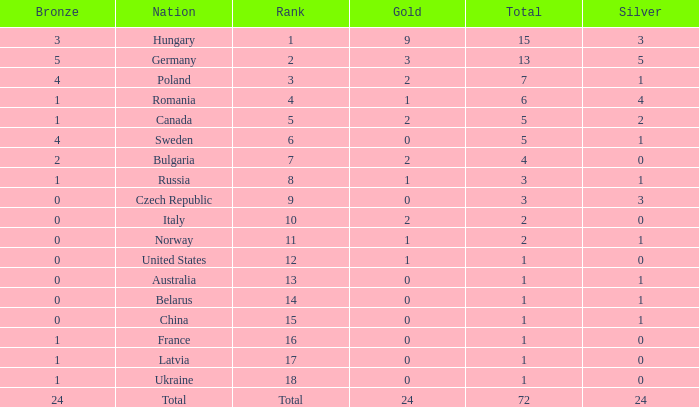What average total has 0 as the gold, with 6 as the rank? 5.0. 